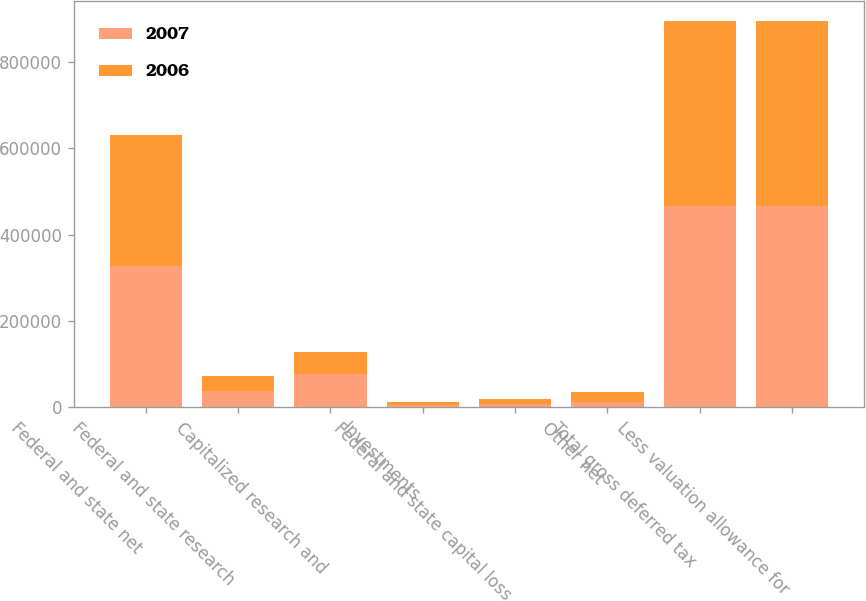Convert chart to OTSL. <chart><loc_0><loc_0><loc_500><loc_500><stacked_bar_chart><ecel><fcel>Federal and state net<fcel>Federal and state research<fcel>Capitalized research and<fcel>Investments<fcel>Federal and state capital loss<fcel>Other net<fcel>Total gross deferred tax<fcel>Less valuation allowance for<nl><fcel>2007<fcel>327000<fcel>37000<fcel>76000<fcel>6000<fcel>8000<fcel>12000<fcel>466000<fcel>466000<nl><fcel>2006<fcel>303000<fcel>35000<fcel>52000<fcel>6000<fcel>11000<fcel>23000<fcel>430000<fcel>430000<nl></chart> 